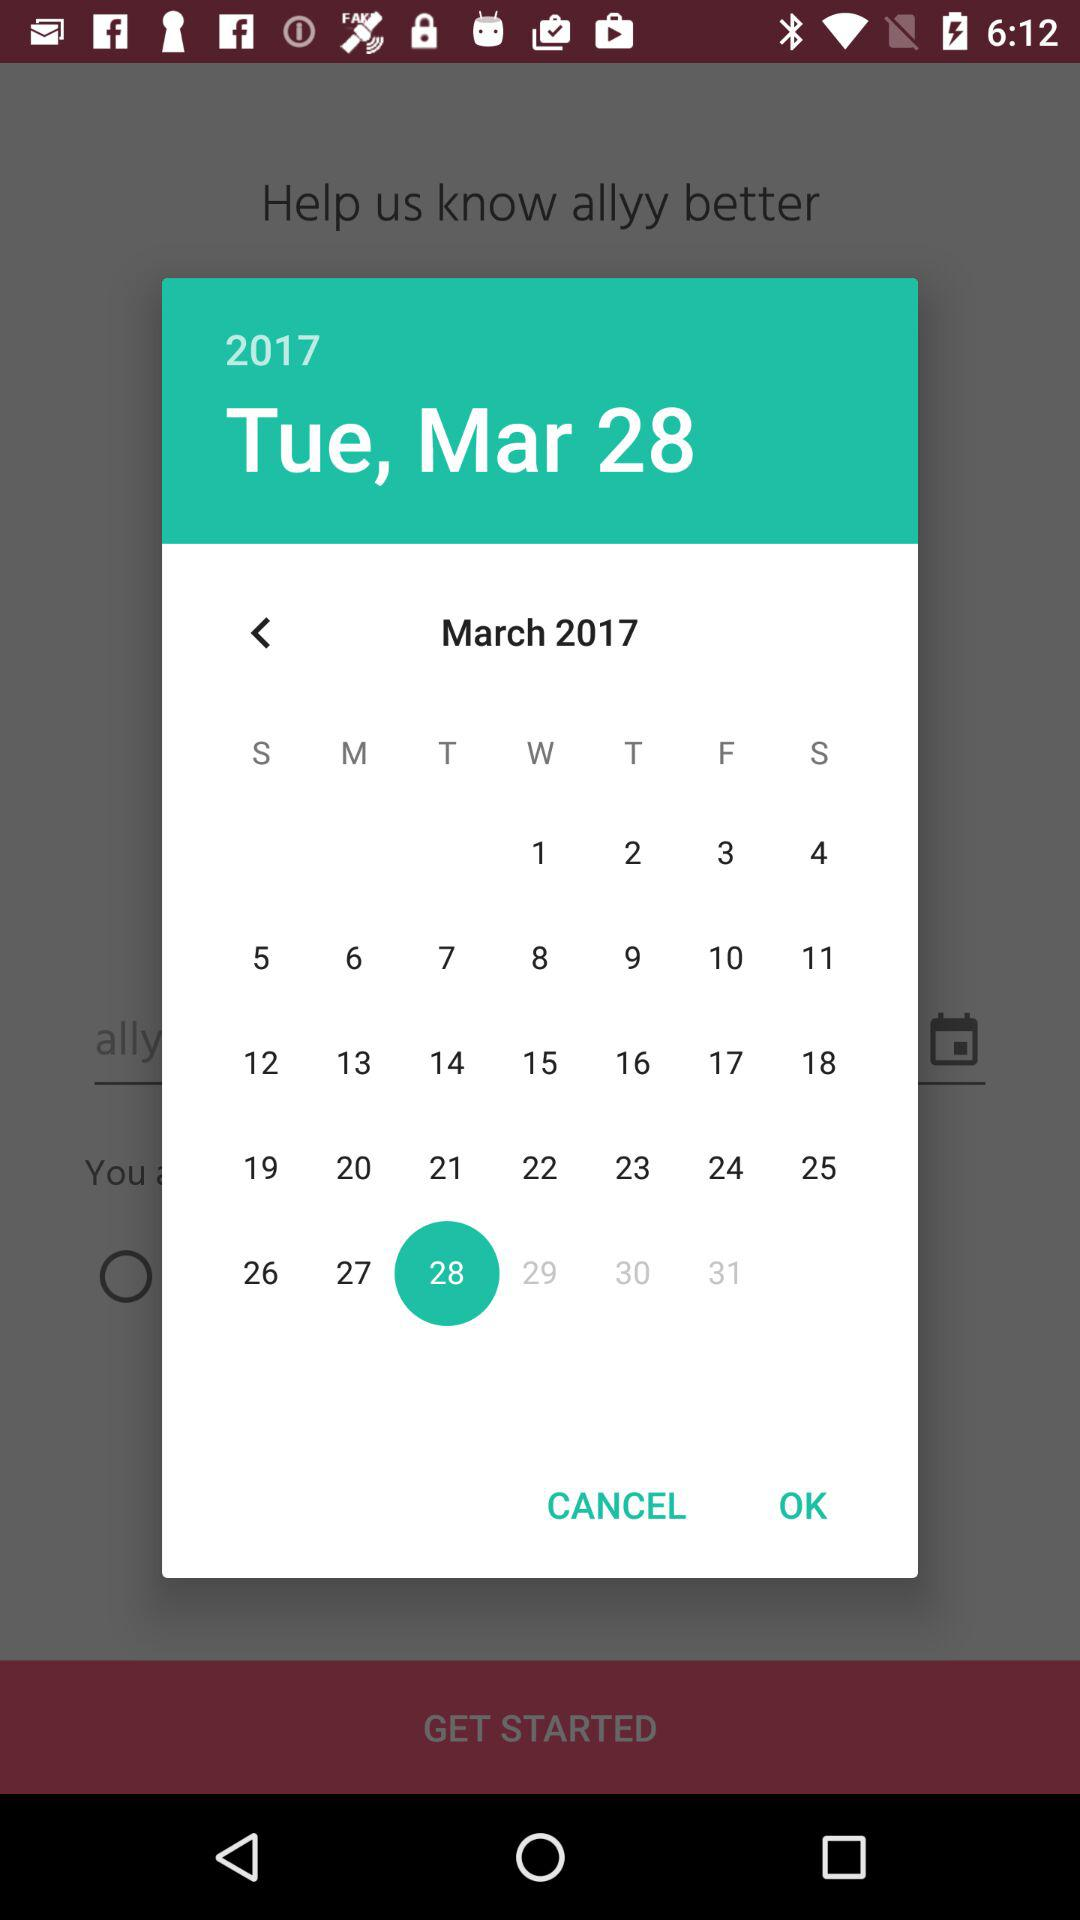What is the selected date? The selected date is Tuesday, March 28, 2017. 